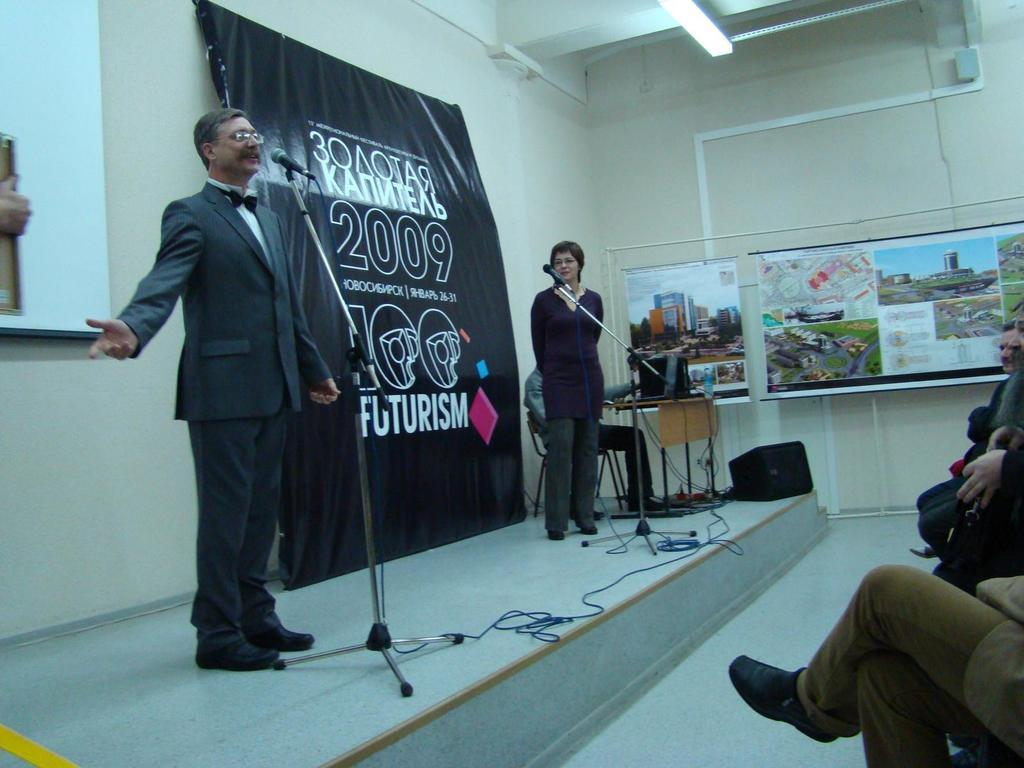<image>
Render a clear and concise summary of the photo. a man and woman on a stage with the number 2009 on the wall behind them. 